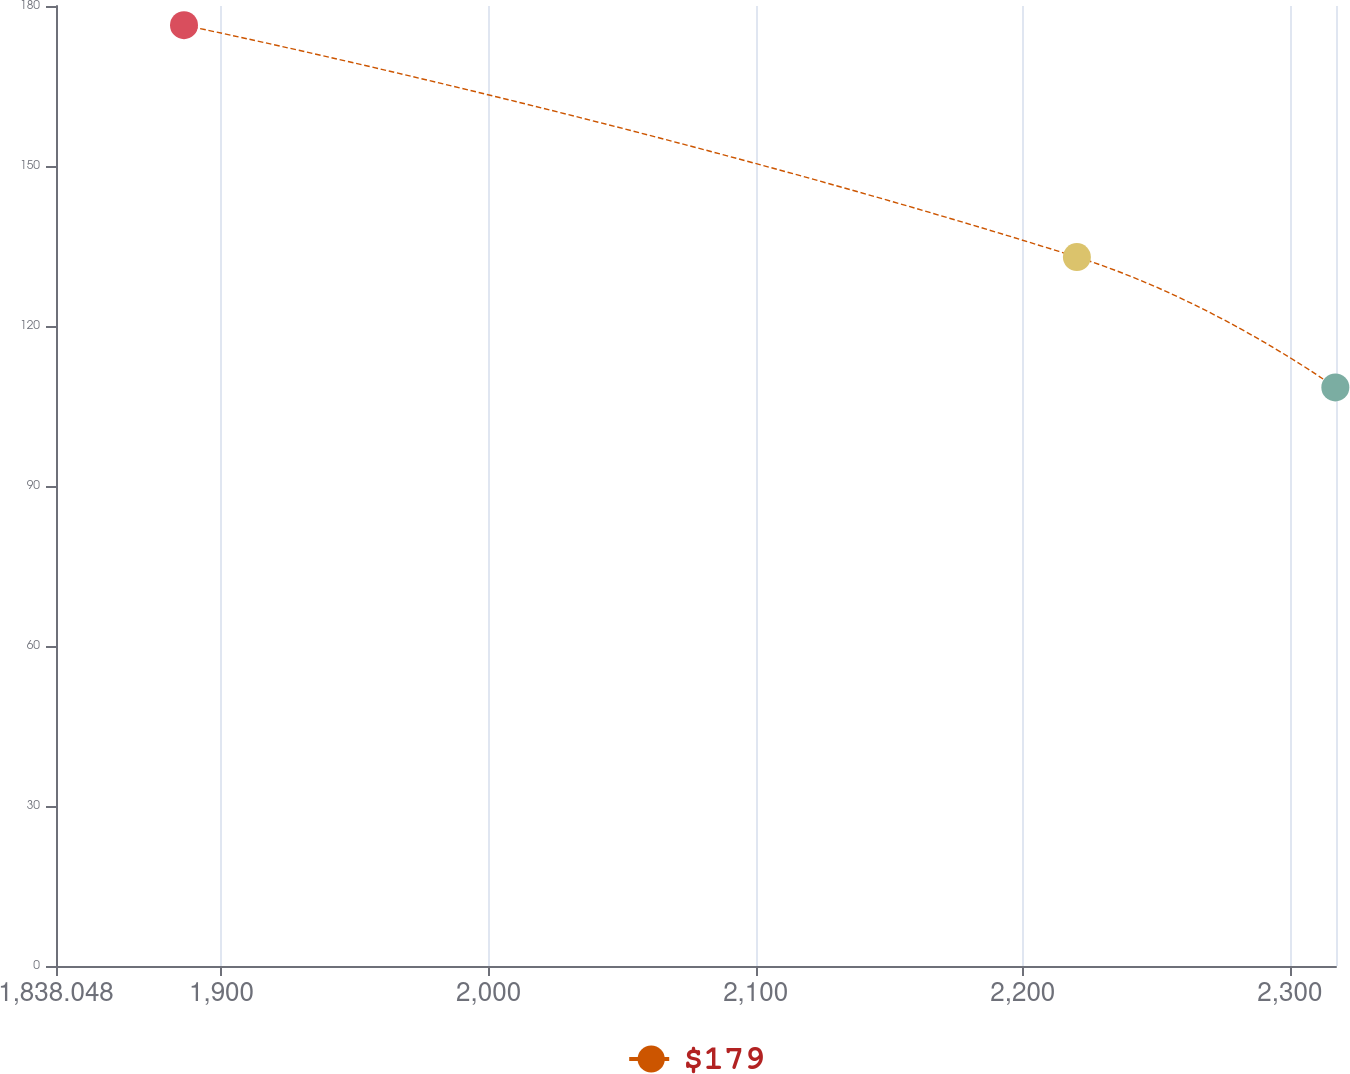Convert chart to OTSL. <chart><loc_0><loc_0><loc_500><loc_500><line_chart><ecel><fcel>$179<nl><fcel>1885.97<fcel>176.4<nl><fcel>2220.26<fcel>132.93<nl><fcel>2317.02<fcel>108.48<nl><fcel>2365.19<fcel>97.41<nl></chart> 